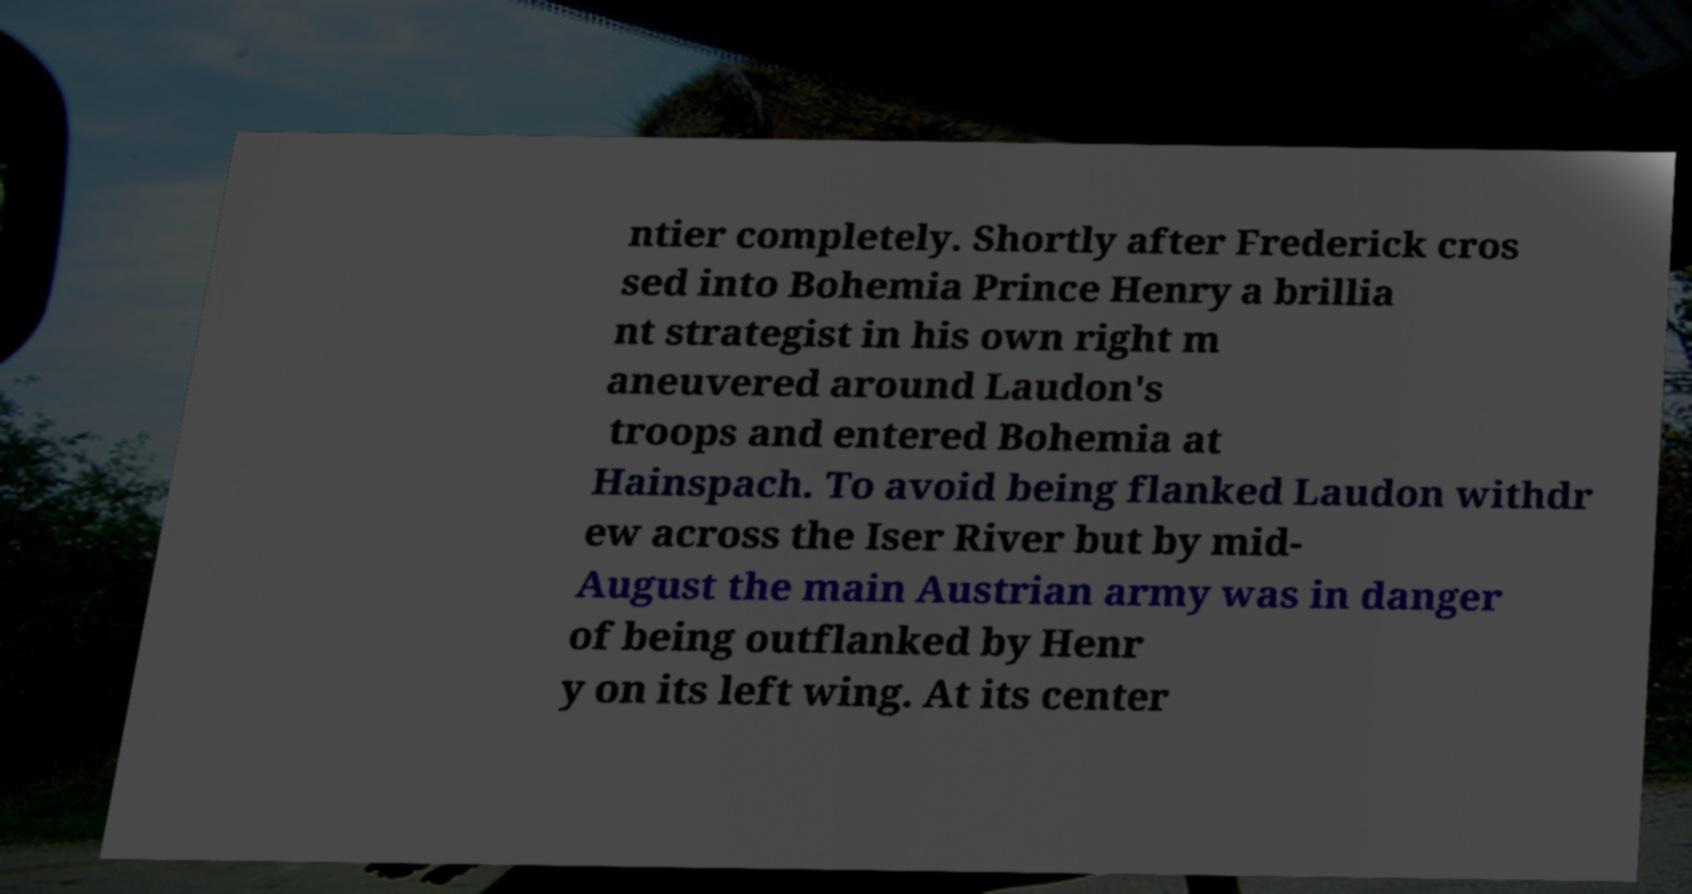Could you assist in decoding the text presented in this image and type it out clearly? ntier completely. Shortly after Frederick cros sed into Bohemia Prince Henry a brillia nt strategist in his own right m aneuvered around Laudon's troops and entered Bohemia at Hainspach. To avoid being flanked Laudon withdr ew across the Iser River but by mid- August the main Austrian army was in danger of being outflanked by Henr y on its left wing. At its center 